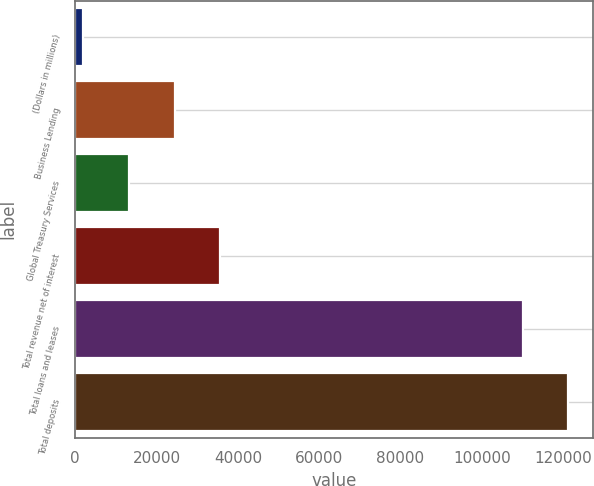Convert chart to OTSL. <chart><loc_0><loc_0><loc_500><loc_500><bar_chart><fcel>(Dollars in millions)<fcel>Business Lending<fcel>Global Treasury Services<fcel>Total revenue net of interest<fcel>Total loans and leases<fcel>Total deposits<nl><fcel>2012<fcel>24446.6<fcel>13229.3<fcel>35663.9<fcel>110109<fcel>121326<nl></chart> 